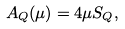<formula> <loc_0><loc_0><loc_500><loc_500>A _ { Q } ( \mu ) = 4 \mu S _ { Q } ,</formula> 